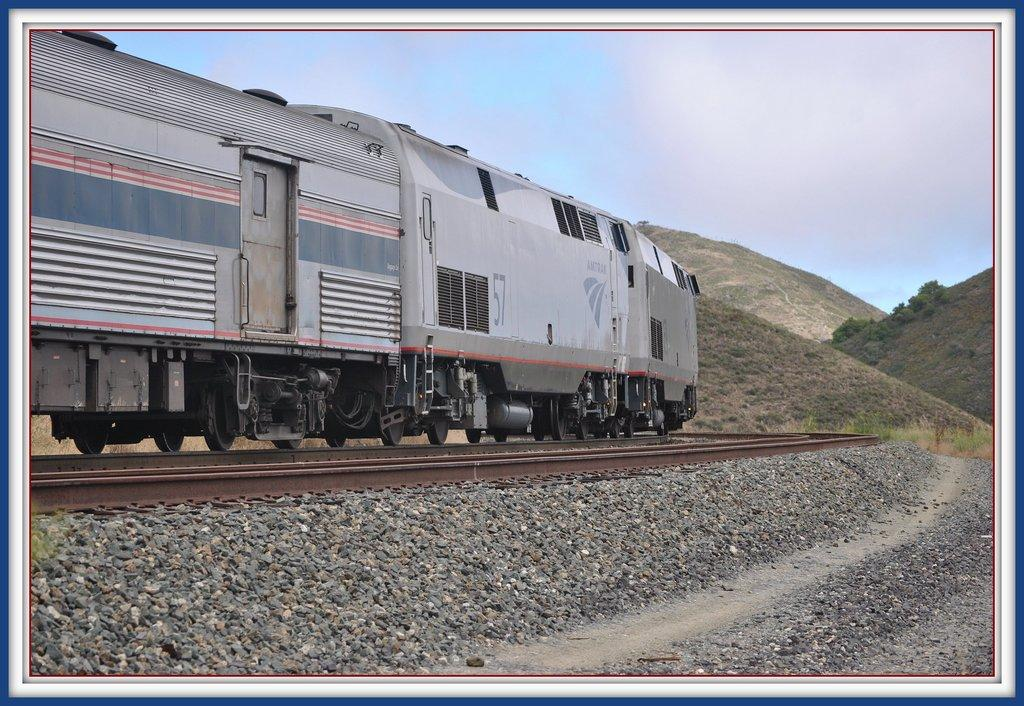What is the nature of the image? The image appears to be edited. What can be seen moving in the image? There is a train moving on the rail track. What type of natural features are visible in the image? There are rocks and hills with plants and trees in the image. What type of dress is the school wearing in the image? There is no school or dress present in the image. What type of milk is being served in the image? There is no milk or serving of milk present in the image. 